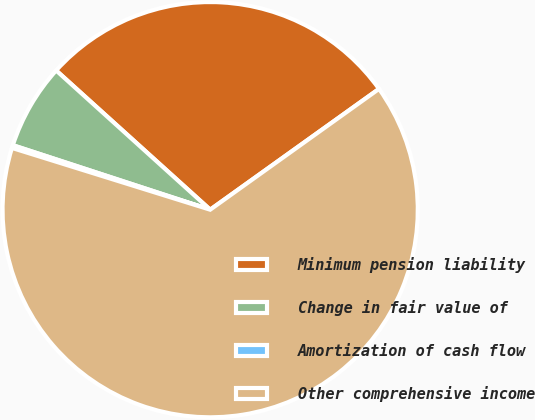Convert chart. <chart><loc_0><loc_0><loc_500><loc_500><pie_chart><fcel>Minimum pension liability<fcel>Change in fair value of<fcel>Amortization of cash flow<fcel>Other comprehensive income<nl><fcel>28.42%<fcel>6.67%<fcel>0.22%<fcel>64.69%<nl></chart> 